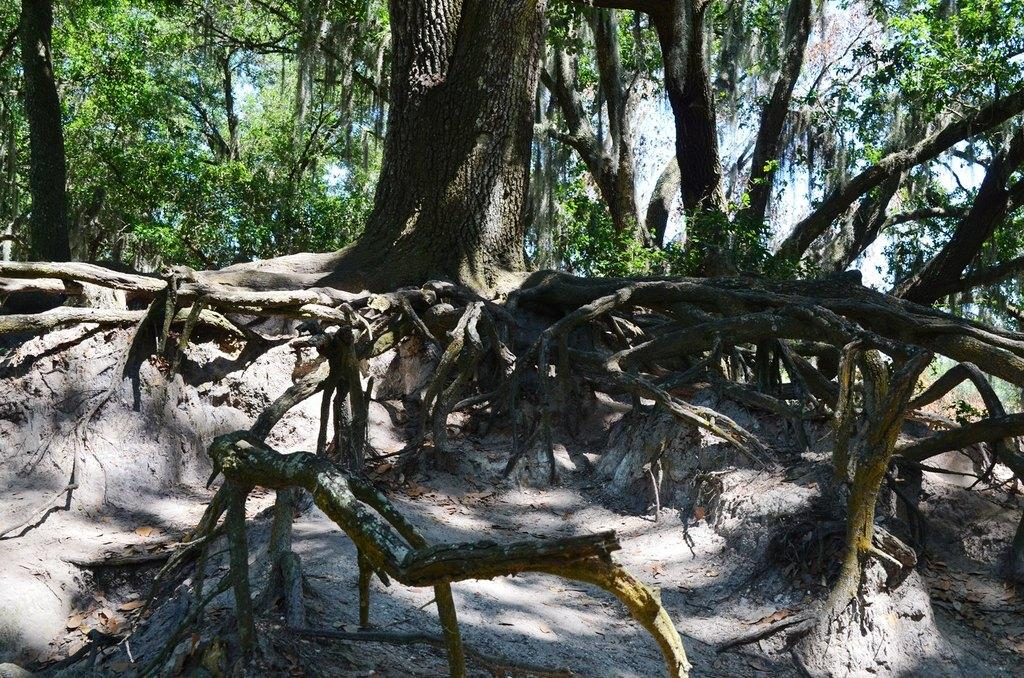What type of vegetation can be seen in the image? There are trees in the image. Can you describe any specific features of the trees? The roots of a tree are visible at the bottom of the image. What is visible in the background of the image? There is sky visible in the background of the image. What type of muscle can be seen flexing in the image? There is: There is no muscle visible in the image; it features trees and their roots. 